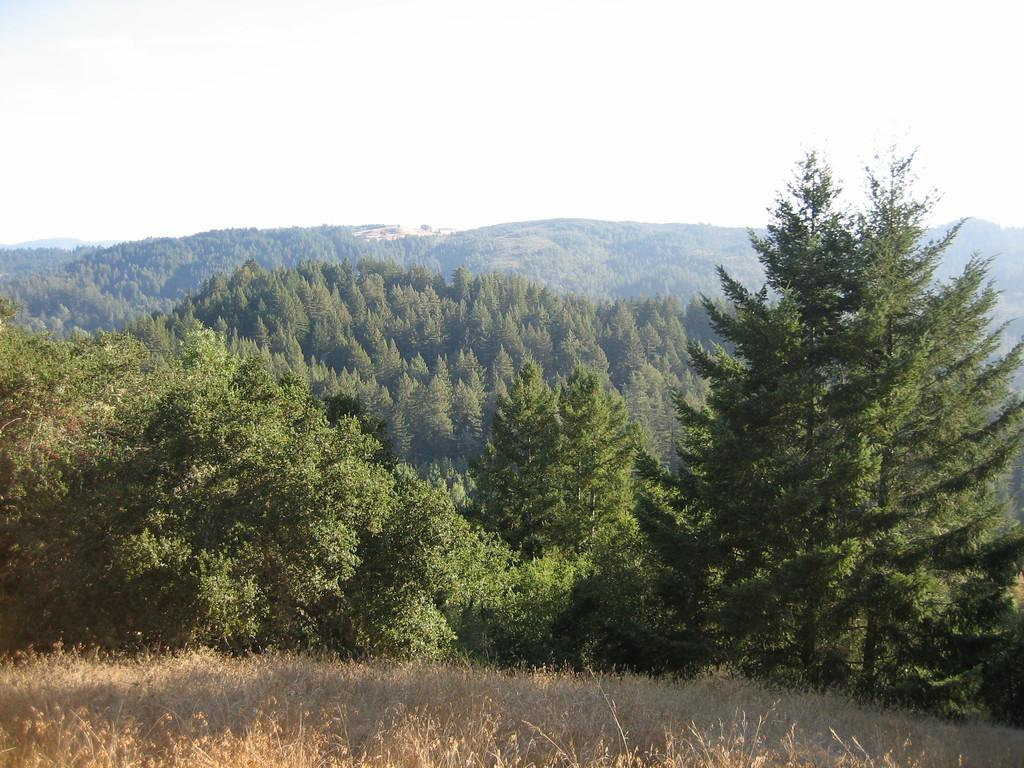What type of vegetation is present in the image? There is grass in the image. What can be seen in the background of the image? There are trees and a mountain in the background of the image. What part of the natural environment is visible in the image? The sky is visible in the background of the image. What type of wrench is being used to fix the rainstorm in the image? There is no wrench or rainstorm present in the image; it features grass, trees, a mountain, and the sky. 